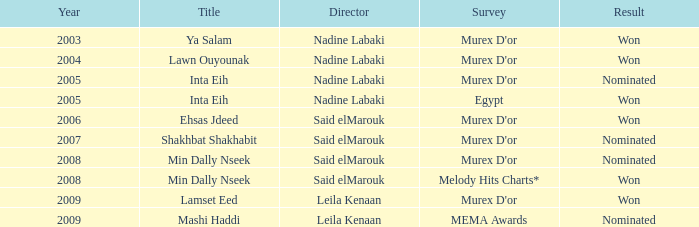What is the name of the murex d'or poll, post-2005, with said elmarouk as the director, and received a nomination? Shakhbat Shakhabit, Min Dally Nseek. I'm looking to parse the entire table for insights. Could you assist me with that? {'header': ['Year', 'Title', 'Director', 'Survey', 'Result'], 'rows': [['2003', 'Ya Salam', 'Nadine Labaki', "Murex D'or", 'Won'], ['2004', 'Lawn Ouyounak', 'Nadine Labaki', "Murex D'or", 'Won'], ['2005', 'Inta Eih', 'Nadine Labaki', "Murex D'or", 'Nominated'], ['2005', 'Inta Eih', 'Nadine Labaki', 'Egypt', 'Won'], ['2006', 'Ehsas Jdeed', 'Said elMarouk', "Murex D'or", 'Won'], ['2007', 'Shakhbat Shakhabit', 'Said elMarouk', "Murex D'or", 'Nominated'], ['2008', 'Min Dally Nseek', 'Said elMarouk', "Murex D'or", 'Nominated'], ['2008', 'Min Dally Nseek', 'Said elMarouk', 'Melody Hits Charts*', 'Won'], ['2009', 'Lamset Eed', 'Leila Kenaan', "Murex D'or", 'Won'], ['2009', 'Mashi Haddi', 'Leila Kenaan', 'MEMA Awards', 'Nominated']]} 